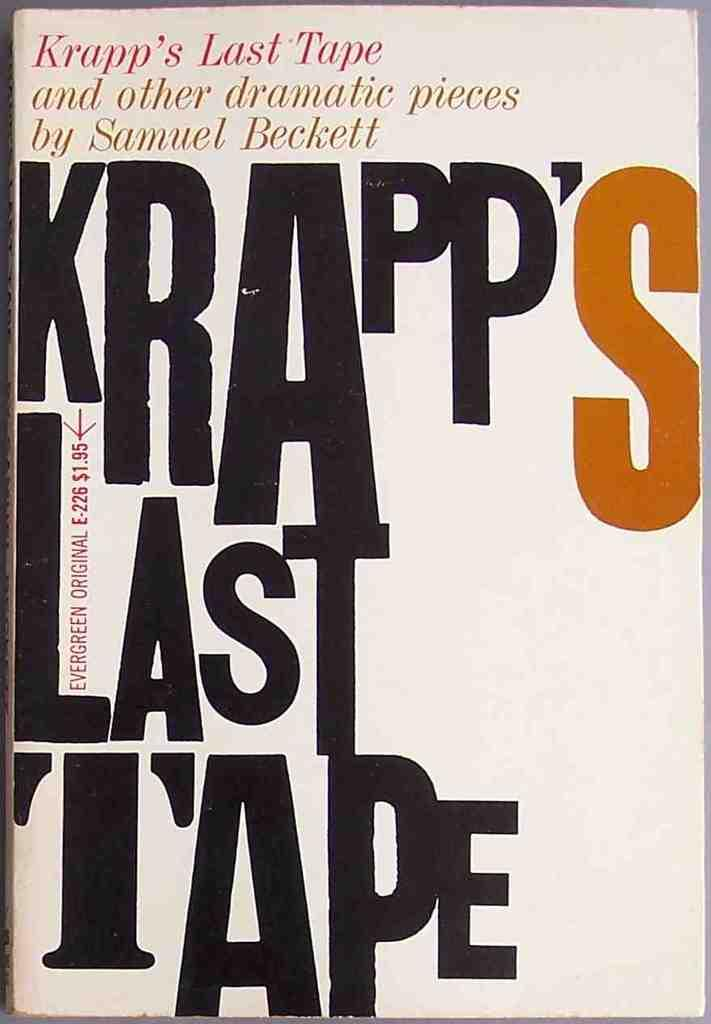<image>
Relay a brief, clear account of the picture shown. A book entitled Krapp's Last Tape is visiable. 